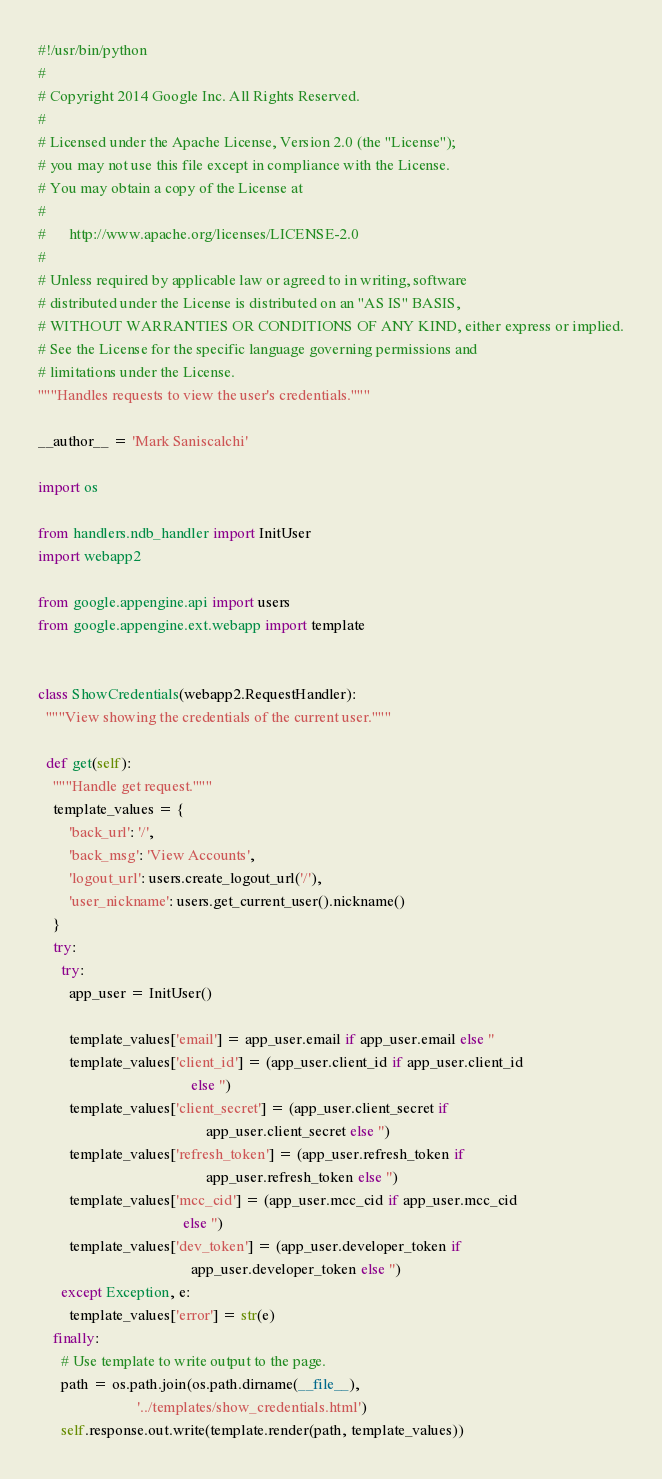Convert code to text. <code><loc_0><loc_0><loc_500><loc_500><_Python_>#!/usr/bin/python
#
# Copyright 2014 Google Inc. All Rights Reserved.
#
# Licensed under the Apache License, Version 2.0 (the "License");
# you may not use this file except in compliance with the License.
# You may obtain a copy of the License at
#
#      http://www.apache.org/licenses/LICENSE-2.0
#
# Unless required by applicable law or agreed to in writing, software
# distributed under the License is distributed on an "AS IS" BASIS,
# WITHOUT WARRANTIES OR CONDITIONS OF ANY KIND, either express or implied.
# See the License for the specific language governing permissions and
# limitations under the License.
"""Handles requests to view the user's credentials."""

__author__ = 'Mark Saniscalchi'

import os

from handlers.ndb_handler import InitUser
import webapp2

from google.appengine.api import users
from google.appengine.ext.webapp import template


class ShowCredentials(webapp2.RequestHandler):
  """View showing the credentials of the current user."""

  def get(self):
    """Handle get request."""
    template_values = {
        'back_url': '/',
        'back_msg': 'View Accounts',
        'logout_url': users.create_logout_url('/'),
        'user_nickname': users.get_current_user().nickname()
    }
    try:
      try:
        app_user = InitUser()

        template_values['email'] = app_user.email if app_user.email else ''
        template_values['client_id'] = (app_user.client_id if app_user.client_id
                                        else '')
        template_values['client_secret'] = (app_user.client_secret if
                                            app_user.client_secret else '')
        template_values['refresh_token'] = (app_user.refresh_token if
                                            app_user.refresh_token else '')
        template_values['mcc_cid'] = (app_user.mcc_cid if app_user.mcc_cid
                                      else '')
        template_values['dev_token'] = (app_user.developer_token if
                                        app_user.developer_token else '')
      except Exception, e:
        template_values['error'] = str(e)
    finally:
      # Use template to write output to the page.
      path = os.path.join(os.path.dirname(__file__),
                          '../templates/show_credentials.html')
      self.response.out.write(template.render(path, template_values))
</code> 